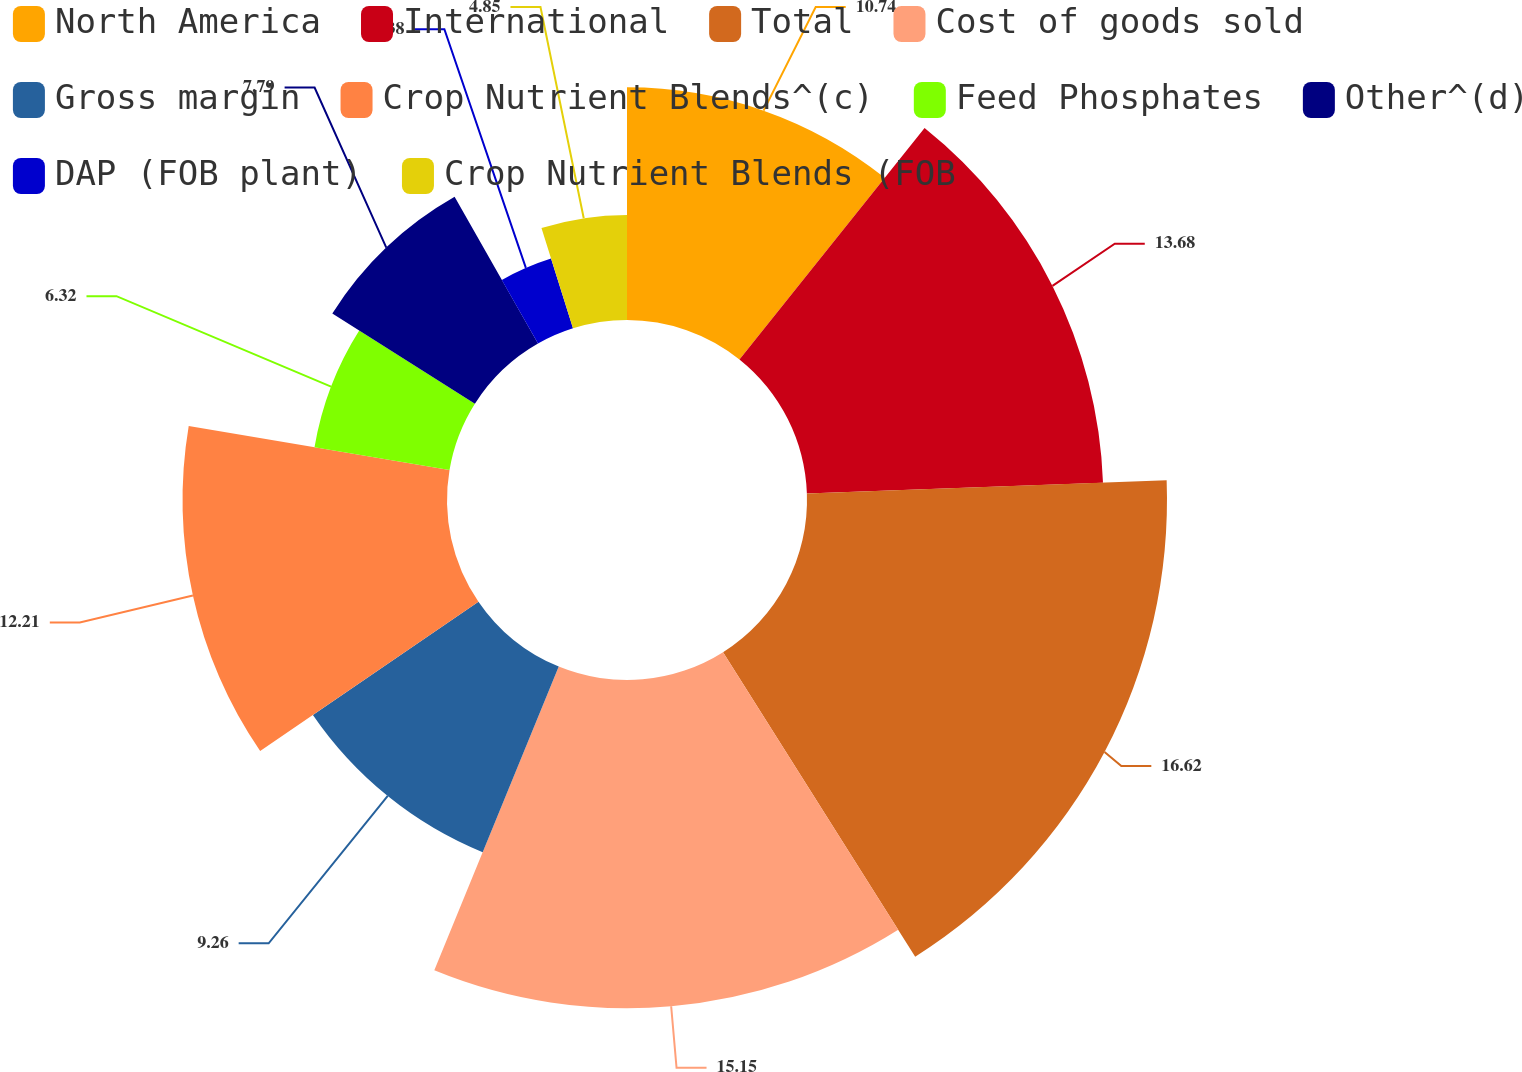Convert chart. <chart><loc_0><loc_0><loc_500><loc_500><pie_chart><fcel>North America<fcel>International<fcel>Total<fcel>Cost of goods sold<fcel>Gross margin<fcel>Crop Nutrient Blends^(c)<fcel>Feed Phosphates<fcel>Other^(d)<fcel>DAP (FOB plant)<fcel>Crop Nutrient Blends (FOB<nl><fcel>10.74%<fcel>13.68%<fcel>16.62%<fcel>15.15%<fcel>9.26%<fcel>12.21%<fcel>6.32%<fcel>7.79%<fcel>3.38%<fcel>4.85%<nl></chart> 